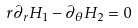<formula> <loc_0><loc_0><loc_500><loc_500>r \partial _ { r } H _ { 1 } - \partial _ { \theta } H _ { 2 } = 0 \</formula> 